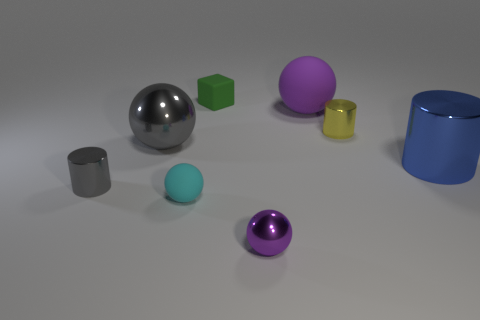Subtract all small purple spheres. How many spheres are left? 3 Subtract all cyan balls. How many balls are left? 3 Add 1 small cubes. How many objects exist? 9 Subtract all blocks. How many objects are left? 7 Add 3 large purple spheres. How many large purple spheres exist? 4 Subtract 1 green cubes. How many objects are left? 7 Subtract all brown cylinders. Subtract all tiny cylinders. How many objects are left? 6 Add 2 big metallic spheres. How many big metallic spheres are left? 3 